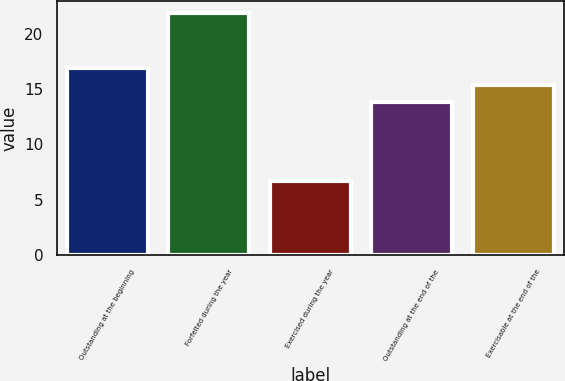Convert chart. <chart><loc_0><loc_0><loc_500><loc_500><bar_chart><fcel>Outstanding at the beginning<fcel>Forfeited during the year<fcel>Exercised during the year<fcel>Outstanding at the end of the<fcel>Exercisable at the end of the<nl><fcel>16.89<fcel>21.9<fcel>6.7<fcel>13.85<fcel>15.37<nl></chart> 